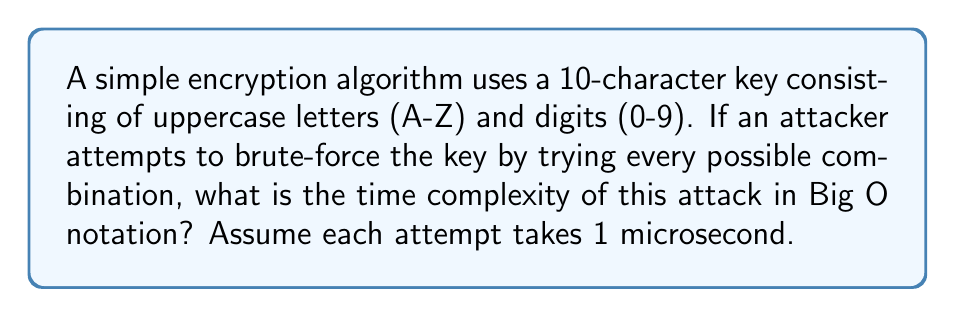Could you help me with this problem? To solve this problem, let's follow these steps:

1. Determine the number of possible characters for each position in the key:
   - Uppercase letters (A-Z): 26
   - Digits (0-9): 10
   - Total possible characters: $26 + 10 = 36$

2. Calculate the total number of possible keys:
   - The key is 10 characters long
   - For each character, we have 36 choices
   - Total number of combinations: $36^{10}$

3. Express the number of combinations in Big O notation:
   - The exact number doesn't matter for Big O, only the order of growth
   - In this case, it's $O(36^{10})$, which can be simplified to $O(n^{10})$ where $n$ represents the character set size

4. Consider the time factor:
   - Each attempt takes 1 microsecond
   - This is a constant factor and doesn't affect the Big O notation

Therefore, the time complexity of brute-forcing this encryption algorithm is $O(n^{10})$, where $n$ is the size of the character set (36 in this case).

Note: While the actual time to brute-force all combinations would be $36^{10}$ microseconds, which is approximately 3,656 years, the time complexity in Big O notation focuses on the growth rate of the algorithm rather than the exact time.
Answer: $O(n^{10})$ 